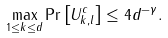<formula> <loc_0><loc_0><loc_500><loc_500>\max _ { 1 \leq k \leq d } \Pr \left [ U _ { k , l } ^ { c } \right ] \leq 4 d ^ { - \gamma } .</formula> 